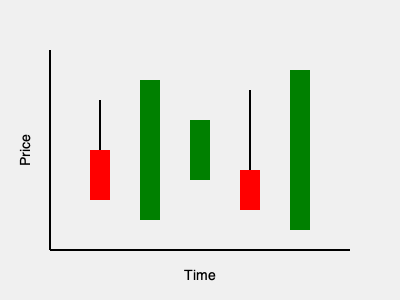Based on the candlestick chart shown, which bullish pattern is most likely formed by the last three candlesticks? To interpret the candlestick pattern, let's analyze the last three candlesticks step-by-step:

1. Candlestick 3 (third from the right):
   - Small green (bullish) candlestick
   - Indicates a small upward movement

2. Candlestick 4 (second from the right):
   - Red (bearish) candlestick
   - Longer body than the previous candlestick
   - Indicates a downward movement

3. Candlestick 5 (rightmost):
   - Large green (bullish) candlestick
   - Significantly longer body than the previous two candlesticks
   - Opens near the close of the previous candlestick and closes above the open of Candlestick 3

This pattern closely resembles a Morning Star pattern, which is a bullish reversal pattern. The Morning Star pattern consists of:
1. A bearish candlestick
2. A small candlestick (either bullish or bearish)
3. A bullish candlestick that closes above the midpoint of the first candlestick

In this case, we see:
1. A bearish (red) candlestick
2. A small bullish (green) candlestick
3. A large bullish (green) candlestick that closes above the midpoint of the first candlestick

The pattern suggests a potential reversal from a downtrend to an uptrend, making the Morning Star the most likely bullish pattern formed by these three candlesticks.
Answer: Morning Star pattern 